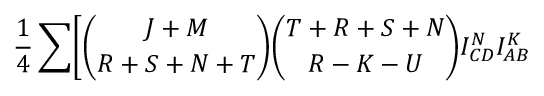<formula> <loc_0><loc_0><loc_500><loc_500>{ \frac { 1 } { 4 } } \sum \Big [ { \binom { J + M } { R + S + N + T } } { \binom { T + R + S + N } { R - K - U } } I _ { C D } ^ { N } I _ { A B } ^ { K }</formula> 